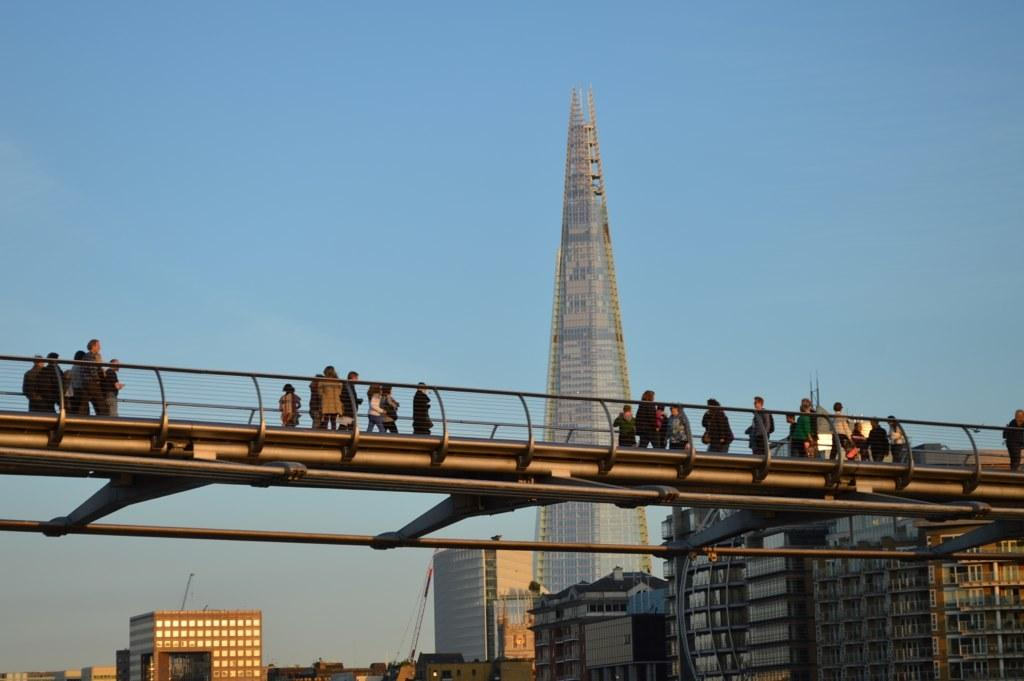What can be seen on the bridge in the image? There are people on the bridge in the image. What type of structures are present in the image? There are buildings and a tower building in the image. What construction equipment is visible in the image? A crane is visible in the image. What is visible in the background of the image? The sky is visible in the background of the image. Can you see a farmer with a baby near the sea in the image? There is no farmer, baby, or sea present in the image. The image features a bridge, buildings, a crane, a tower building, and the sky. 